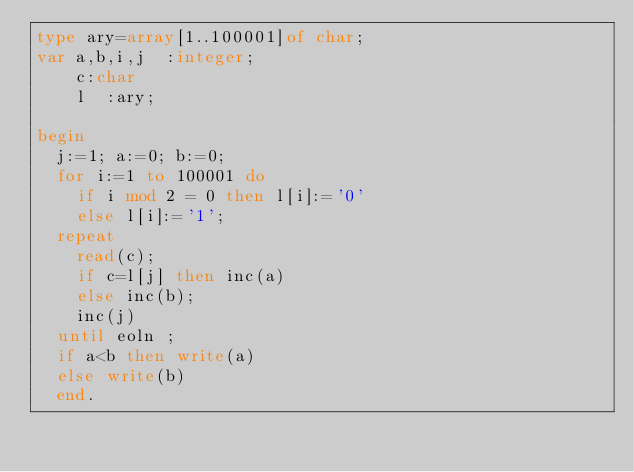<code> <loc_0><loc_0><loc_500><loc_500><_Pascal_>type ary=array[1..100001]of char;
var a,b,i,j  :integer;
    c:char
    l  :ary;
    
begin
  j:=1; a:=0; b:=0;
  for i:=1 to 100001 do 
    if i mod 2 = 0 then l[i]:='0'
    else l[i]:='1';
  repeat
    read(c);
    if c=l[j] then inc(a)
    else inc(b);
    inc(j)
  until eoln ;
  if a<b then write(a) 
  else write(b)
  end.</code> 